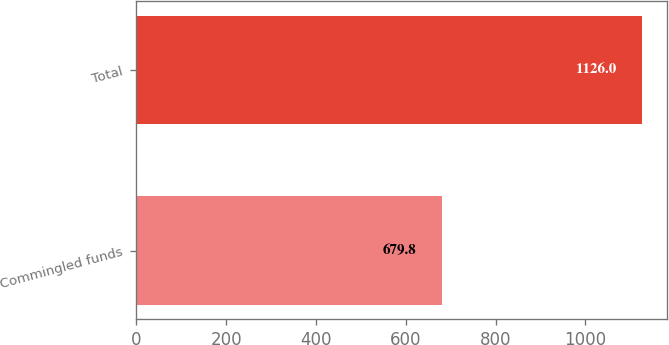Convert chart. <chart><loc_0><loc_0><loc_500><loc_500><bar_chart><fcel>Commingled funds<fcel>Total<nl><fcel>679.8<fcel>1126<nl></chart> 